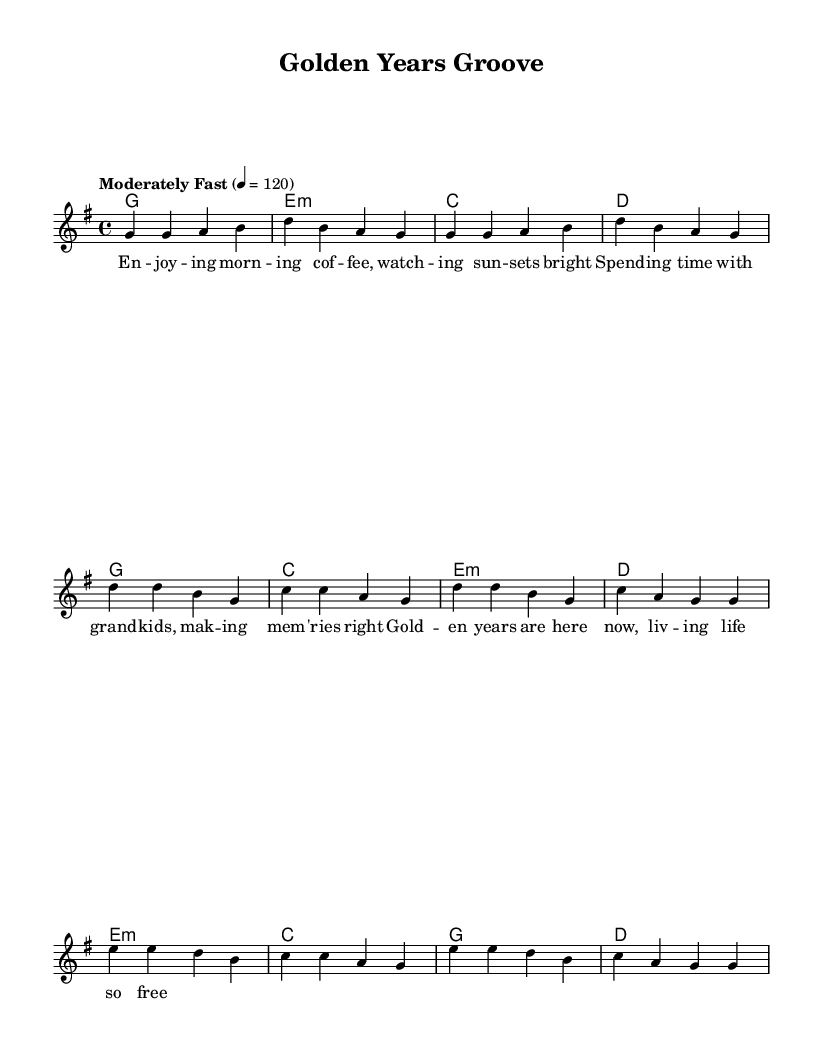What is the key signature of this music? The key signature is G major, which has one sharp (F#). This can be identified by looking at the key signature at the beginning of the sheet music.
Answer: G major What is the time signature of this music? The time signature is 4/4, which means there are four beats in a measure and the quarter note gets one beat. This can be found by examining the time signature indicated in the sheet music.
Answer: 4/4 What is the tempo marking for this piece? The tempo marking is "Moderately Fast," and it is set to 120 beats per minute. This is found directly above the staff, indicating how fast the music should be played.
Answer: Moderately Fast How many measures are in the chorus section? The chorus section contains 4 measures, which can be counted by identifying the sections in the sheet music, particularly where the chorus is marked.
Answer: 4 measures What is the first note of the melody? The first note of the melody is G, which is the note that appears at the start of the melody line in the sheet music.
Answer: G Which harmony chord is associated with the first measure of the verse? The harmony chord for the first measure of the verse is G major, which is indicated under the first measure of the melody.
Answer: G What lyrical theme does this song convey? The lyrical theme conveyed in the song is about enjoying simple pleasures in retirement, as suggested by the lyrics that mention enjoying coffee and spending time with family.
Answer: Enjoying simple pleasures 